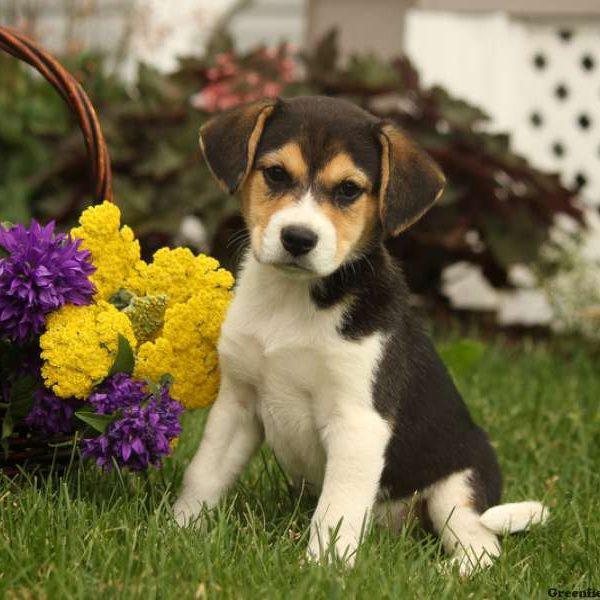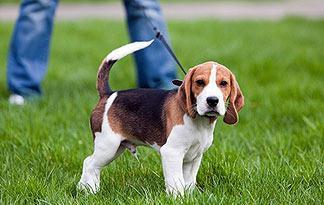The first image is the image on the left, the second image is the image on the right. Evaluate the accuracy of this statement regarding the images: "A dog in one image has a toy in his mouth.". Is it true? Answer yes or no. No. 